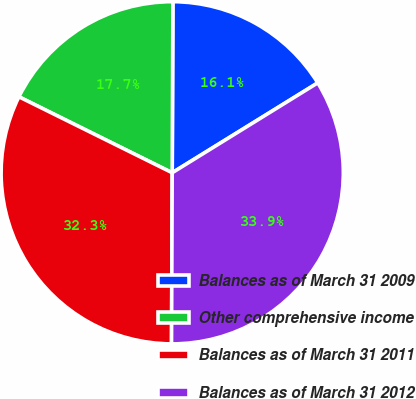<chart> <loc_0><loc_0><loc_500><loc_500><pie_chart><fcel>Balances as of March 31 2009<fcel>Other comprehensive income<fcel>Balances as of March 31 2011<fcel>Balances as of March 31 2012<nl><fcel>16.13%<fcel>17.74%<fcel>32.26%<fcel>33.87%<nl></chart> 